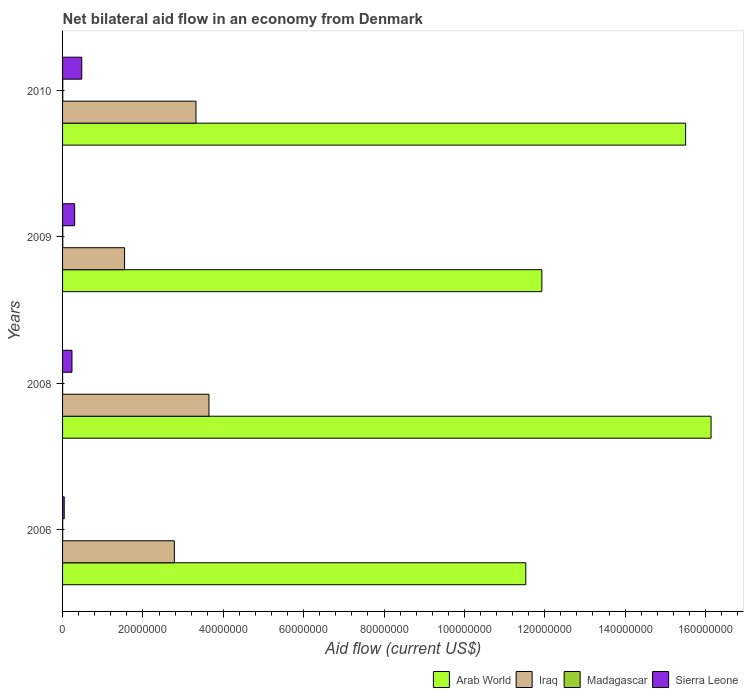Are the number of bars on each tick of the Y-axis equal?
Give a very brief answer. Yes. How many bars are there on the 1st tick from the bottom?
Keep it short and to the point. 4. What is the net bilateral aid flow in Sierra Leone in 2006?
Your answer should be compact. 4.10e+05. Across all years, what is the maximum net bilateral aid flow in Madagascar?
Provide a succinct answer. 5.00e+04. Across all years, what is the minimum net bilateral aid flow in Sierra Leone?
Make the answer very short. 4.10e+05. What is the total net bilateral aid flow in Iraq in the graph?
Make the answer very short. 1.13e+08. What is the difference between the net bilateral aid flow in Sierra Leone in 2008 and that in 2010?
Offer a terse response. -2.44e+06. What is the difference between the net bilateral aid flow in Iraq in 2006 and the net bilateral aid flow in Arab World in 2009?
Make the answer very short. -9.15e+07. What is the average net bilateral aid flow in Iraq per year?
Keep it short and to the point. 2.82e+07. In the year 2008, what is the difference between the net bilateral aid flow in Sierra Leone and net bilateral aid flow in Madagascar?
Your answer should be compact. 2.33e+06. Is the net bilateral aid flow in Iraq in 2006 less than that in 2008?
Your response must be concise. Yes. Is the difference between the net bilateral aid flow in Sierra Leone in 2009 and 2010 greater than the difference between the net bilateral aid flow in Madagascar in 2009 and 2010?
Ensure brevity in your answer.  No. What is the difference between the highest and the second highest net bilateral aid flow in Iraq?
Offer a very short reply. 3.23e+06. What is the difference between the highest and the lowest net bilateral aid flow in Sierra Leone?
Your answer should be compact. 4.37e+06. In how many years, is the net bilateral aid flow in Arab World greater than the average net bilateral aid flow in Arab World taken over all years?
Provide a short and direct response. 2. Is it the case that in every year, the sum of the net bilateral aid flow in Arab World and net bilateral aid flow in Sierra Leone is greater than the sum of net bilateral aid flow in Madagascar and net bilateral aid flow in Iraq?
Give a very brief answer. Yes. What does the 2nd bar from the top in 2008 represents?
Your response must be concise. Madagascar. What does the 4th bar from the bottom in 2010 represents?
Your answer should be very brief. Sierra Leone. Is it the case that in every year, the sum of the net bilateral aid flow in Iraq and net bilateral aid flow in Madagascar is greater than the net bilateral aid flow in Arab World?
Provide a short and direct response. No. Does the graph contain any zero values?
Make the answer very short. No. How are the legend labels stacked?
Keep it short and to the point. Horizontal. What is the title of the graph?
Your answer should be compact. Net bilateral aid flow in an economy from Denmark. What is the label or title of the X-axis?
Offer a very short reply. Aid flow (current US$). What is the label or title of the Y-axis?
Provide a succinct answer. Years. What is the Aid flow (current US$) of Arab World in 2006?
Provide a succinct answer. 1.15e+08. What is the Aid flow (current US$) of Iraq in 2006?
Ensure brevity in your answer.  2.78e+07. What is the Aid flow (current US$) of Arab World in 2008?
Offer a very short reply. 1.61e+08. What is the Aid flow (current US$) of Iraq in 2008?
Ensure brevity in your answer.  3.64e+07. What is the Aid flow (current US$) in Sierra Leone in 2008?
Offer a terse response. 2.34e+06. What is the Aid flow (current US$) in Arab World in 2009?
Your answer should be compact. 1.19e+08. What is the Aid flow (current US$) of Iraq in 2009?
Provide a succinct answer. 1.54e+07. What is the Aid flow (current US$) in Sierra Leone in 2009?
Make the answer very short. 3.01e+06. What is the Aid flow (current US$) in Arab World in 2010?
Give a very brief answer. 1.55e+08. What is the Aid flow (current US$) in Iraq in 2010?
Your response must be concise. 3.32e+07. What is the Aid flow (current US$) of Madagascar in 2010?
Make the answer very short. 5.00e+04. What is the Aid flow (current US$) in Sierra Leone in 2010?
Make the answer very short. 4.78e+06. Across all years, what is the maximum Aid flow (current US$) of Arab World?
Provide a succinct answer. 1.61e+08. Across all years, what is the maximum Aid flow (current US$) of Iraq?
Offer a terse response. 3.64e+07. Across all years, what is the maximum Aid flow (current US$) of Sierra Leone?
Your response must be concise. 4.78e+06. Across all years, what is the minimum Aid flow (current US$) in Arab World?
Make the answer very short. 1.15e+08. Across all years, what is the minimum Aid flow (current US$) in Iraq?
Offer a terse response. 1.54e+07. What is the total Aid flow (current US$) in Arab World in the graph?
Offer a very short reply. 5.51e+08. What is the total Aid flow (current US$) of Iraq in the graph?
Offer a terse response. 1.13e+08. What is the total Aid flow (current US$) in Sierra Leone in the graph?
Your response must be concise. 1.05e+07. What is the difference between the Aid flow (current US$) in Arab World in 2006 and that in 2008?
Make the answer very short. -4.61e+07. What is the difference between the Aid flow (current US$) of Iraq in 2006 and that in 2008?
Give a very brief answer. -8.61e+06. What is the difference between the Aid flow (current US$) of Sierra Leone in 2006 and that in 2008?
Your answer should be compact. -1.93e+06. What is the difference between the Aid flow (current US$) of Arab World in 2006 and that in 2009?
Your answer should be very brief. -4.00e+06. What is the difference between the Aid flow (current US$) of Iraq in 2006 and that in 2009?
Give a very brief answer. 1.24e+07. What is the difference between the Aid flow (current US$) in Madagascar in 2006 and that in 2009?
Offer a very short reply. -2.00e+04. What is the difference between the Aid flow (current US$) in Sierra Leone in 2006 and that in 2009?
Offer a terse response. -2.60e+06. What is the difference between the Aid flow (current US$) in Arab World in 2006 and that in 2010?
Offer a very short reply. -3.98e+07. What is the difference between the Aid flow (current US$) of Iraq in 2006 and that in 2010?
Make the answer very short. -5.38e+06. What is the difference between the Aid flow (current US$) of Madagascar in 2006 and that in 2010?
Your response must be concise. -2.00e+04. What is the difference between the Aid flow (current US$) in Sierra Leone in 2006 and that in 2010?
Provide a short and direct response. -4.37e+06. What is the difference between the Aid flow (current US$) in Arab World in 2008 and that in 2009?
Your answer should be very brief. 4.21e+07. What is the difference between the Aid flow (current US$) of Iraq in 2008 and that in 2009?
Your answer should be very brief. 2.10e+07. What is the difference between the Aid flow (current US$) in Madagascar in 2008 and that in 2009?
Offer a very short reply. -4.00e+04. What is the difference between the Aid flow (current US$) of Sierra Leone in 2008 and that in 2009?
Your answer should be very brief. -6.70e+05. What is the difference between the Aid flow (current US$) of Arab World in 2008 and that in 2010?
Offer a terse response. 6.33e+06. What is the difference between the Aid flow (current US$) of Iraq in 2008 and that in 2010?
Your answer should be very brief. 3.23e+06. What is the difference between the Aid flow (current US$) of Sierra Leone in 2008 and that in 2010?
Offer a terse response. -2.44e+06. What is the difference between the Aid flow (current US$) in Arab World in 2009 and that in 2010?
Provide a succinct answer. -3.58e+07. What is the difference between the Aid flow (current US$) in Iraq in 2009 and that in 2010?
Your answer should be compact. -1.78e+07. What is the difference between the Aid flow (current US$) in Madagascar in 2009 and that in 2010?
Offer a very short reply. 0. What is the difference between the Aid flow (current US$) in Sierra Leone in 2009 and that in 2010?
Offer a very short reply. -1.77e+06. What is the difference between the Aid flow (current US$) in Arab World in 2006 and the Aid flow (current US$) in Iraq in 2008?
Your answer should be very brief. 7.88e+07. What is the difference between the Aid flow (current US$) of Arab World in 2006 and the Aid flow (current US$) of Madagascar in 2008?
Give a very brief answer. 1.15e+08. What is the difference between the Aid flow (current US$) in Arab World in 2006 and the Aid flow (current US$) in Sierra Leone in 2008?
Give a very brief answer. 1.13e+08. What is the difference between the Aid flow (current US$) of Iraq in 2006 and the Aid flow (current US$) of Madagascar in 2008?
Your response must be concise. 2.78e+07. What is the difference between the Aid flow (current US$) of Iraq in 2006 and the Aid flow (current US$) of Sierra Leone in 2008?
Your answer should be compact. 2.55e+07. What is the difference between the Aid flow (current US$) in Madagascar in 2006 and the Aid flow (current US$) in Sierra Leone in 2008?
Offer a terse response. -2.31e+06. What is the difference between the Aid flow (current US$) of Arab World in 2006 and the Aid flow (current US$) of Iraq in 2009?
Ensure brevity in your answer.  9.98e+07. What is the difference between the Aid flow (current US$) in Arab World in 2006 and the Aid flow (current US$) in Madagascar in 2009?
Provide a succinct answer. 1.15e+08. What is the difference between the Aid flow (current US$) in Arab World in 2006 and the Aid flow (current US$) in Sierra Leone in 2009?
Provide a short and direct response. 1.12e+08. What is the difference between the Aid flow (current US$) in Iraq in 2006 and the Aid flow (current US$) in Madagascar in 2009?
Your answer should be very brief. 2.78e+07. What is the difference between the Aid flow (current US$) in Iraq in 2006 and the Aid flow (current US$) in Sierra Leone in 2009?
Give a very brief answer. 2.48e+07. What is the difference between the Aid flow (current US$) of Madagascar in 2006 and the Aid flow (current US$) of Sierra Leone in 2009?
Your response must be concise. -2.98e+06. What is the difference between the Aid flow (current US$) of Arab World in 2006 and the Aid flow (current US$) of Iraq in 2010?
Your answer should be compact. 8.21e+07. What is the difference between the Aid flow (current US$) of Arab World in 2006 and the Aid flow (current US$) of Madagascar in 2010?
Offer a terse response. 1.15e+08. What is the difference between the Aid flow (current US$) in Arab World in 2006 and the Aid flow (current US$) in Sierra Leone in 2010?
Keep it short and to the point. 1.10e+08. What is the difference between the Aid flow (current US$) of Iraq in 2006 and the Aid flow (current US$) of Madagascar in 2010?
Make the answer very short. 2.78e+07. What is the difference between the Aid flow (current US$) of Iraq in 2006 and the Aid flow (current US$) of Sierra Leone in 2010?
Your answer should be very brief. 2.30e+07. What is the difference between the Aid flow (current US$) of Madagascar in 2006 and the Aid flow (current US$) of Sierra Leone in 2010?
Keep it short and to the point. -4.75e+06. What is the difference between the Aid flow (current US$) of Arab World in 2008 and the Aid flow (current US$) of Iraq in 2009?
Give a very brief answer. 1.46e+08. What is the difference between the Aid flow (current US$) in Arab World in 2008 and the Aid flow (current US$) in Madagascar in 2009?
Your answer should be compact. 1.61e+08. What is the difference between the Aid flow (current US$) of Arab World in 2008 and the Aid flow (current US$) of Sierra Leone in 2009?
Make the answer very short. 1.58e+08. What is the difference between the Aid flow (current US$) of Iraq in 2008 and the Aid flow (current US$) of Madagascar in 2009?
Give a very brief answer. 3.64e+07. What is the difference between the Aid flow (current US$) of Iraq in 2008 and the Aid flow (current US$) of Sierra Leone in 2009?
Offer a terse response. 3.34e+07. What is the difference between the Aid flow (current US$) of Arab World in 2008 and the Aid flow (current US$) of Iraq in 2010?
Your answer should be very brief. 1.28e+08. What is the difference between the Aid flow (current US$) in Arab World in 2008 and the Aid flow (current US$) in Madagascar in 2010?
Give a very brief answer. 1.61e+08. What is the difference between the Aid flow (current US$) of Arab World in 2008 and the Aid flow (current US$) of Sierra Leone in 2010?
Give a very brief answer. 1.57e+08. What is the difference between the Aid flow (current US$) in Iraq in 2008 and the Aid flow (current US$) in Madagascar in 2010?
Offer a terse response. 3.64e+07. What is the difference between the Aid flow (current US$) of Iraq in 2008 and the Aid flow (current US$) of Sierra Leone in 2010?
Give a very brief answer. 3.16e+07. What is the difference between the Aid flow (current US$) in Madagascar in 2008 and the Aid flow (current US$) in Sierra Leone in 2010?
Offer a very short reply. -4.77e+06. What is the difference between the Aid flow (current US$) of Arab World in 2009 and the Aid flow (current US$) of Iraq in 2010?
Give a very brief answer. 8.61e+07. What is the difference between the Aid flow (current US$) of Arab World in 2009 and the Aid flow (current US$) of Madagascar in 2010?
Make the answer very short. 1.19e+08. What is the difference between the Aid flow (current US$) of Arab World in 2009 and the Aid flow (current US$) of Sierra Leone in 2010?
Your answer should be very brief. 1.14e+08. What is the difference between the Aid flow (current US$) in Iraq in 2009 and the Aid flow (current US$) in Madagascar in 2010?
Ensure brevity in your answer.  1.54e+07. What is the difference between the Aid flow (current US$) of Iraq in 2009 and the Aid flow (current US$) of Sierra Leone in 2010?
Ensure brevity in your answer.  1.06e+07. What is the difference between the Aid flow (current US$) in Madagascar in 2009 and the Aid flow (current US$) in Sierra Leone in 2010?
Offer a terse response. -4.73e+06. What is the average Aid flow (current US$) of Arab World per year?
Provide a succinct answer. 1.38e+08. What is the average Aid flow (current US$) of Iraq per year?
Your response must be concise. 2.82e+07. What is the average Aid flow (current US$) in Madagascar per year?
Your answer should be compact. 3.50e+04. What is the average Aid flow (current US$) of Sierra Leone per year?
Your response must be concise. 2.64e+06. In the year 2006, what is the difference between the Aid flow (current US$) of Arab World and Aid flow (current US$) of Iraq?
Keep it short and to the point. 8.75e+07. In the year 2006, what is the difference between the Aid flow (current US$) of Arab World and Aid flow (current US$) of Madagascar?
Offer a very short reply. 1.15e+08. In the year 2006, what is the difference between the Aid flow (current US$) in Arab World and Aid flow (current US$) in Sierra Leone?
Ensure brevity in your answer.  1.15e+08. In the year 2006, what is the difference between the Aid flow (current US$) in Iraq and Aid flow (current US$) in Madagascar?
Give a very brief answer. 2.78e+07. In the year 2006, what is the difference between the Aid flow (current US$) in Iraq and Aid flow (current US$) in Sierra Leone?
Your response must be concise. 2.74e+07. In the year 2006, what is the difference between the Aid flow (current US$) in Madagascar and Aid flow (current US$) in Sierra Leone?
Keep it short and to the point. -3.80e+05. In the year 2008, what is the difference between the Aid flow (current US$) in Arab World and Aid flow (current US$) in Iraq?
Ensure brevity in your answer.  1.25e+08. In the year 2008, what is the difference between the Aid flow (current US$) in Arab World and Aid flow (current US$) in Madagascar?
Provide a succinct answer. 1.61e+08. In the year 2008, what is the difference between the Aid flow (current US$) in Arab World and Aid flow (current US$) in Sierra Leone?
Provide a short and direct response. 1.59e+08. In the year 2008, what is the difference between the Aid flow (current US$) of Iraq and Aid flow (current US$) of Madagascar?
Keep it short and to the point. 3.64e+07. In the year 2008, what is the difference between the Aid flow (current US$) in Iraq and Aid flow (current US$) in Sierra Leone?
Offer a very short reply. 3.41e+07. In the year 2008, what is the difference between the Aid flow (current US$) of Madagascar and Aid flow (current US$) of Sierra Leone?
Offer a very short reply. -2.33e+06. In the year 2009, what is the difference between the Aid flow (current US$) of Arab World and Aid flow (current US$) of Iraq?
Make the answer very short. 1.04e+08. In the year 2009, what is the difference between the Aid flow (current US$) in Arab World and Aid flow (current US$) in Madagascar?
Offer a very short reply. 1.19e+08. In the year 2009, what is the difference between the Aid flow (current US$) of Arab World and Aid flow (current US$) of Sierra Leone?
Provide a succinct answer. 1.16e+08. In the year 2009, what is the difference between the Aid flow (current US$) of Iraq and Aid flow (current US$) of Madagascar?
Give a very brief answer. 1.54e+07. In the year 2009, what is the difference between the Aid flow (current US$) in Iraq and Aid flow (current US$) in Sierra Leone?
Offer a terse response. 1.24e+07. In the year 2009, what is the difference between the Aid flow (current US$) in Madagascar and Aid flow (current US$) in Sierra Leone?
Make the answer very short. -2.96e+06. In the year 2010, what is the difference between the Aid flow (current US$) in Arab World and Aid flow (current US$) in Iraq?
Keep it short and to the point. 1.22e+08. In the year 2010, what is the difference between the Aid flow (current US$) of Arab World and Aid flow (current US$) of Madagascar?
Your response must be concise. 1.55e+08. In the year 2010, what is the difference between the Aid flow (current US$) in Arab World and Aid flow (current US$) in Sierra Leone?
Offer a very short reply. 1.50e+08. In the year 2010, what is the difference between the Aid flow (current US$) of Iraq and Aid flow (current US$) of Madagascar?
Give a very brief answer. 3.32e+07. In the year 2010, what is the difference between the Aid flow (current US$) in Iraq and Aid flow (current US$) in Sierra Leone?
Ensure brevity in your answer.  2.84e+07. In the year 2010, what is the difference between the Aid flow (current US$) in Madagascar and Aid flow (current US$) in Sierra Leone?
Provide a succinct answer. -4.73e+06. What is the ratio of the Aid flow (current US$) in Arab World in 2006 to that in 2008?
Provide a short and direct response. 0.71. What is the ratio of the Aid flow (current US$) in Iraq in 2006 to that in 2008?
Offer a very short reply. 0.76. What is the ratio of the Aid flow (current US$) in Sierra Leone in 2006 to that in 2008?
Provide a short and direct response. 0.18. What is the ratio of the Aid flow (current US$) in Arab World in 2006 to that in 2009?
Keep it short and to the point. 0.97. What is the ratio of the Aid flow (current US$) of Iraq in 2006 to that in 2009?
Provide a succinct answer. 1.8. What is the ratio of the Aid flow (current US$) of Sierra Leone in 2006 to that in 2009?
Your answer should be very brief. 0.14. What is the ratio of the Aid flow (current US$) of Arab World in 2006 to that in 2010?
Ensure brevity in your answer.  0.74. What is the ratio of the Aid flow (current US$) of Iraq in 2006 to that in 2010?
Offer a very short reply. 0.84. What is the ratio of the Aid flow (current US$) in Sierra Leone in 2006 to that in 2010?
Your answer should be very brief. 0.09. What is the ratio of the Aid flow (current US$) in Arab World in 2008 to that in 2009?
Your answer should be very brief. 1.35. What is the ratio of the Aid flow (current US$) in Iraq in 2008 to that in 2009?
Provide a succinct answer. 2.36. What is the ratio of the Aid flow (current US$) in Sierra Leone in 2008 to that in 2009?
Keep it short and to the point. 0.78. What is the ratio of the Aid flow (current US$) of Arab World in 2008 to that in 2010?
Your answer should be very brief. 1.04. What is the ratio of the Aid flow (current US$) of Iraq in 2008 to that in 2010?
Keep it short and to the point. 1.1. What is the ratio of the Aid flow (current US$) in Sierra Leone in 2008 to that in 2010?
Give a very brief answer. 0.49. What is the ratio of the Aid flow (current US$) of Arab World in 2009 to that in 2010?
Your answer should be compact. 0.77. What is the ratio of the Aid flow (current US$) of Iraq in 2009 to that in 2010?
Offer a terse response. 0.46. What is the ratio of the Aid flow (current US$) of Sierra Leone in 2009 to that in 2010?
Provide a succinct answer. 0.63. What is the difference between the highest and the second highest Aid flow (current US$) of Arab World?
Make the answer very short. 6.33e+06. What is the difference between the highest and the second highest Aid flow (current US$) of Iraq?
Make the answer very short. 3.23e+06. What is the difference between the highest and the second highest Aid flow (current US$) in Madagascar?
Offer a terse response. 0. What is the difference between the highest and the second highest Aid flow (current US$) of Sierra Leone?
Your response must be concise. 1.77e+06. What is the difference between the highest and the lowest Aid flow (current US$) of Arab World?
Offer a very short reply. 4.61e+07. What is the difference between the highest and the lowest Aid flow (current US$) in Iraq?
Ensure brevity in your answer.  2.10e+07. What is the difference between the highest and the lowest Aid flow (current US$) of Madagascar?
Give a very brief answer. 4.00e+04. What is the difference between the highest and the lowest Aid flow (current US$) of Sierra Leone?
Keep it short and to the point. 4.37e+06. 